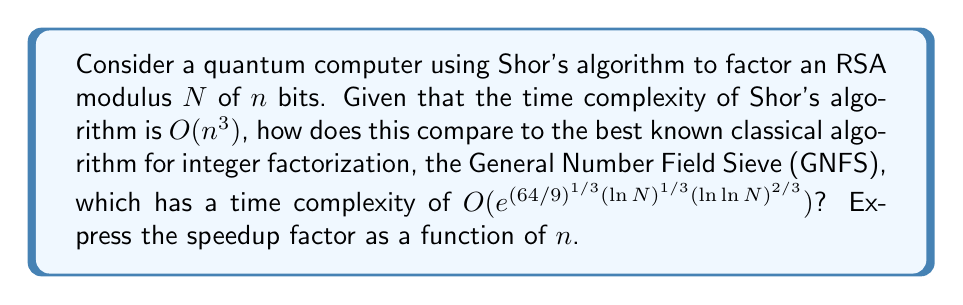Could you help me with this problem? To compare the time complexities and determine the speedup factor, we'll follow these steps:

1) Shor's algorithm time complexity: $O(n^3)$

2) GNFS time complexity: $O(e^{(64/9)^{1/3}(\ln N)^{1/3}(\ln \ln N)^{2/3}})$

3) Express $N$ in terms of $n$:
   $N$ is an $n$-bit number, so $N \approx 2^n$

4) Substitute into GNFS complexity:
   $O(e^{(64/9)^{1/3}(\ln 2^n)^{1/3}(\ln \ln 2^n)^{2/3}})$
   $= O(e^{(64/9)^{1/3}(n \ln 2)^{1/3}(\ln n + \ln \ln 2)^{2/3}})$

5) Simplify, noting that $\ln \ln 2$ is negligible for large $n$:
   $\approx O(e^{(64/9)^{1/3}(n \ln 2)^{1/3}(\ln n)^{2/3}})$

6) The speedup factor is the ratio of GNFS to Shor's algorithm:
   $\frac{e^{(64/9)^{1/3}(n \ln 2)^{1/3}(\ln n)^{2/3}}}{n^3}$

7) Simplify by taking the natural log of both sides:
   $\ln(\text{speedup}) = (64/9)^{1/3}(n \ln 2)^{1/3}(\ln n)^{2/3} - 3\ln n$

8) For large $n$, the first term dominates, so we can approximate:
   $\ln(\text{speedup}) \approx (64/9)^{1/3}(n \ln 2)^{1/3}(\ln n)^{2/3}$

9) Finally, express the speedup factor:
   $\text{speedup} \approx e^{(64/9)^{1/3}(n \ln 2)^{1/3}(\ln n)^{2/3}}$
Answer: $e^{(64/9)^{1/3}(n \ln 2)^{1/3}(\ln n)^{2/3}}$ 